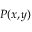<formula> <loc_0><loc_0><loc_500><loc_500>P ( x , y )</formula> 